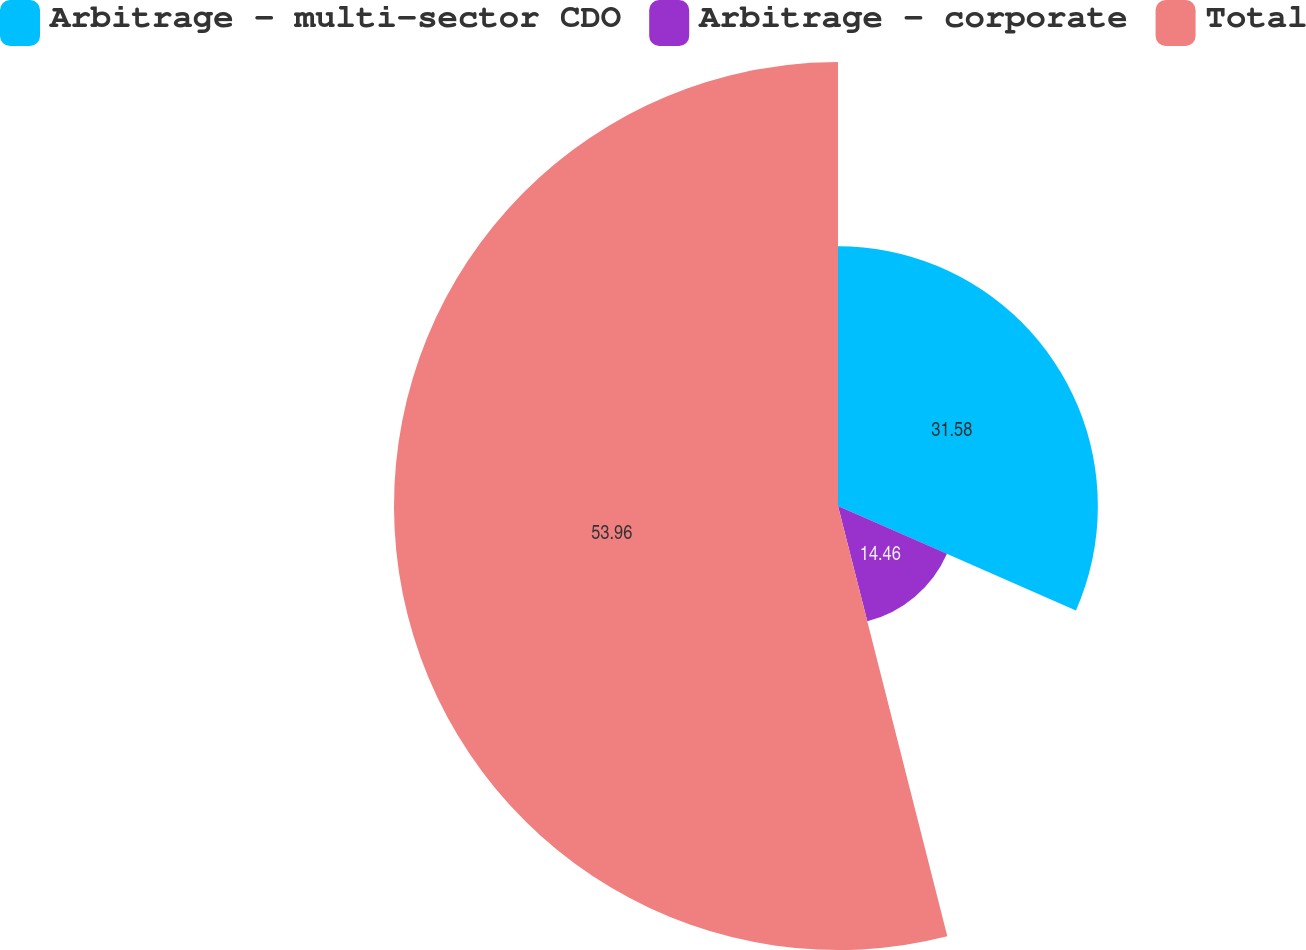Convert chart to OTSL. <chart><loc_0><loc_0><loc_500><loc_500><pie_chart><fcel>Arbitrage - multi-sector CDO<fcel>Arbitrage - corporate<fcel>Total<nl><fcel>31.58%<fcel>14.46%<fcel>53.96%<nl></chart> 